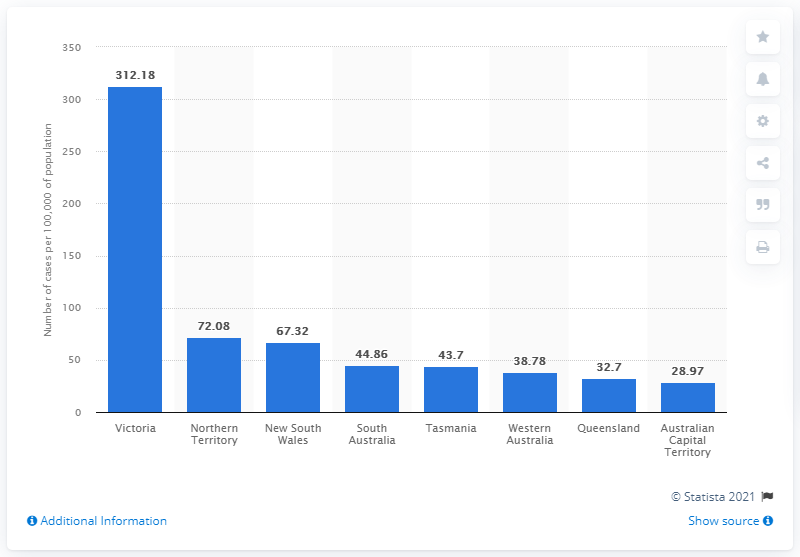Specify some key components in this picture. The COVID-19 rate per 100,000 people in Victoria was 312.18 as of June 22, 2021. 